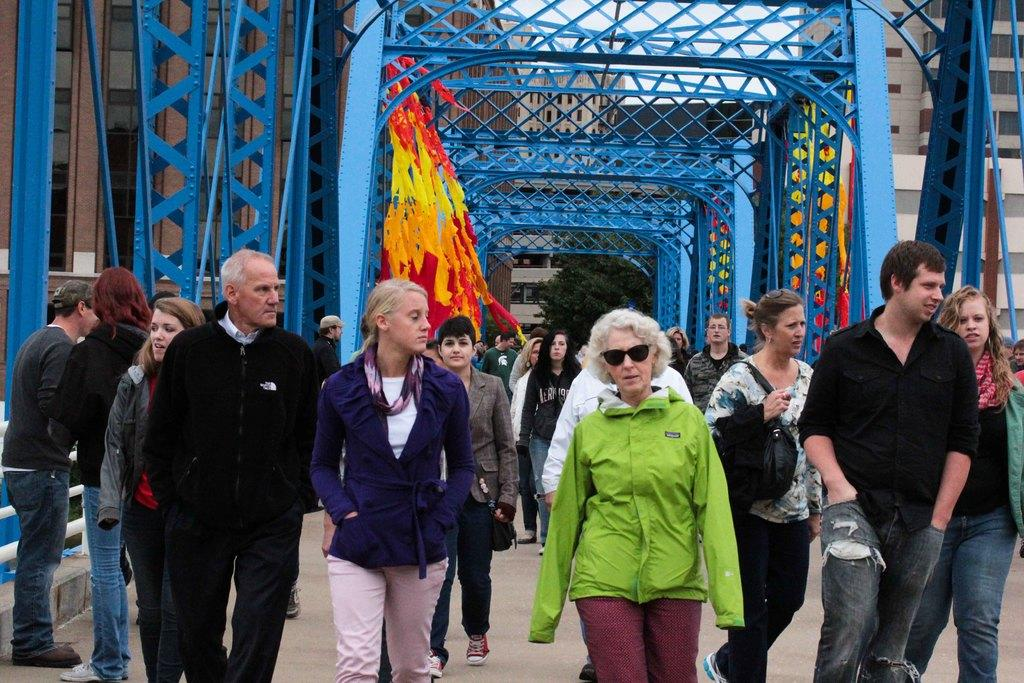What are the people in the image doing? The persons in the image are walking on the road. What can be seen near the road in the image? There is railing visible in the image. What is visible in the background of the image? In the background of the image, there are rods, buildings, glasses, trees, and other objects. The sky is also visible. Where can the cherries be found in the image? There are no cherries present in the image. What type of balls are being used by the people walking on the road? There are no balls visible in the image; the people are simply walking on the road. 